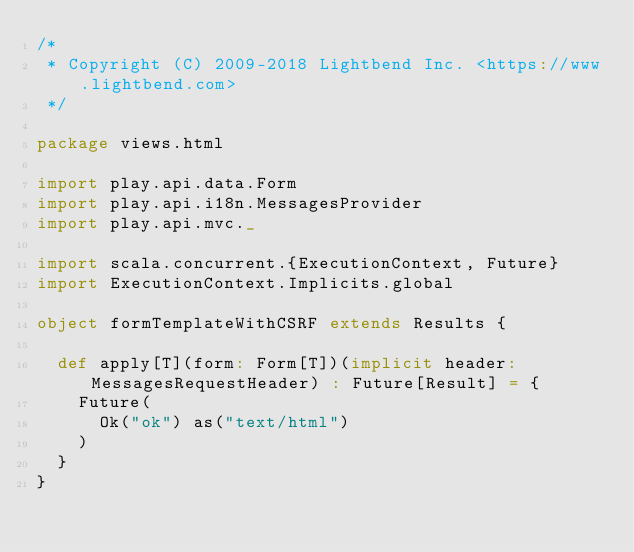Convert code to text. <code><loc_0><loc_0><loc_500><loc_500><_Scala_>/*
 * Copyright (C) 2009-2018 Lightbend Inc. <https://www.lightbend.com>
 */

package views.html

import play.api.data.Form
import play.api.i18n.MessagesProvider
import play.api.mvc._

import scala.concurrent.{ExecutionContext, Future}
import ExecutionContext.Implicits.global

object formTemplateWithCSRF extends Results {

  def apply[T](form: Form[T])(implicit header: MessagesRequestHeader) : Future[Result] = {
    Future(
      Ok("ok") as("text/html")
    )
  }
}
</code> 